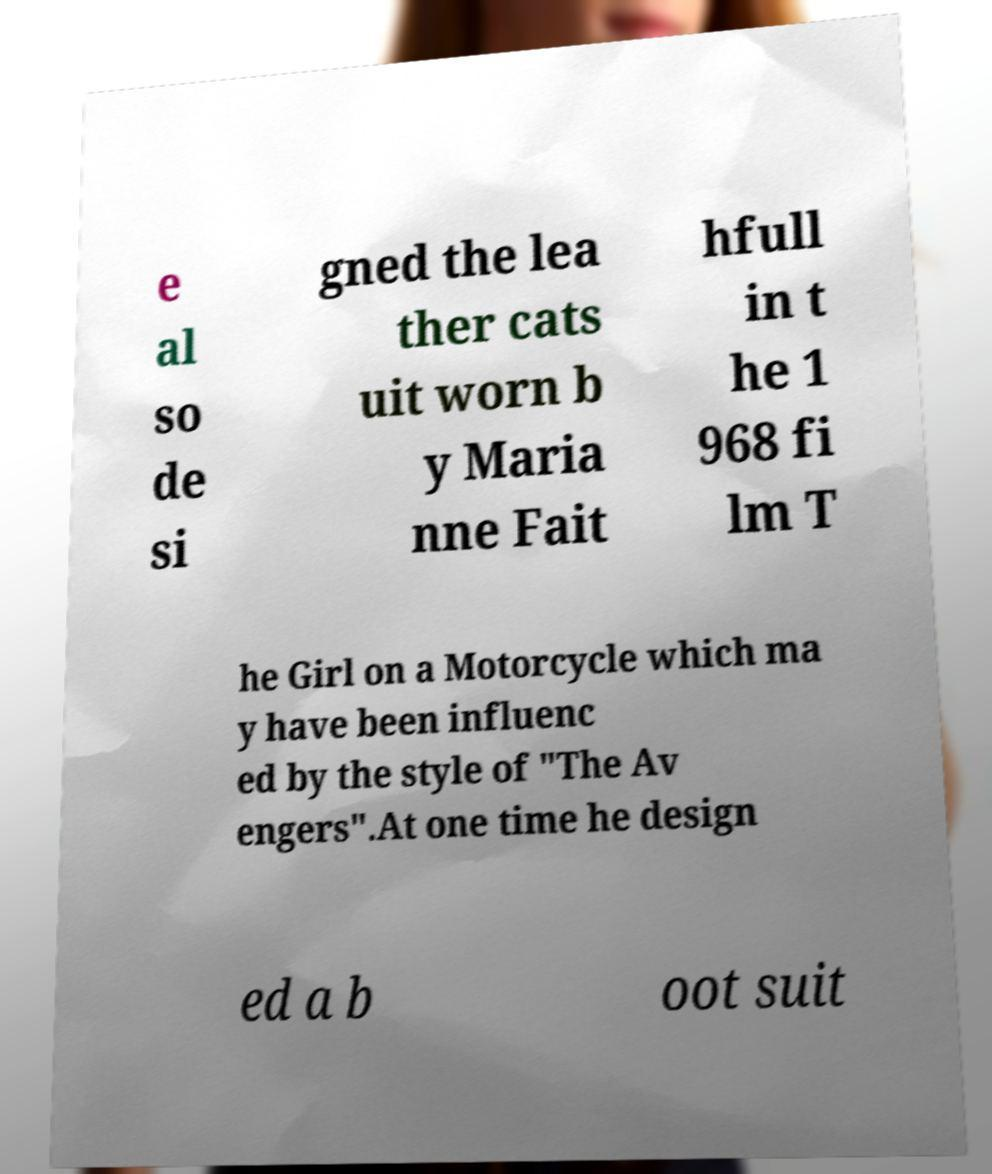There's text embedded in this image that I need extracted. Can you transcribe it verbatim? e al so de si gned the lea ther cats uit worn b y Maria nne Fait hfull in t he 1 968 fi lm T he Girl on a Motorcycle which ma y have been influenc ed by the style of "The Av engers".At one time he design ed a b oot suit 